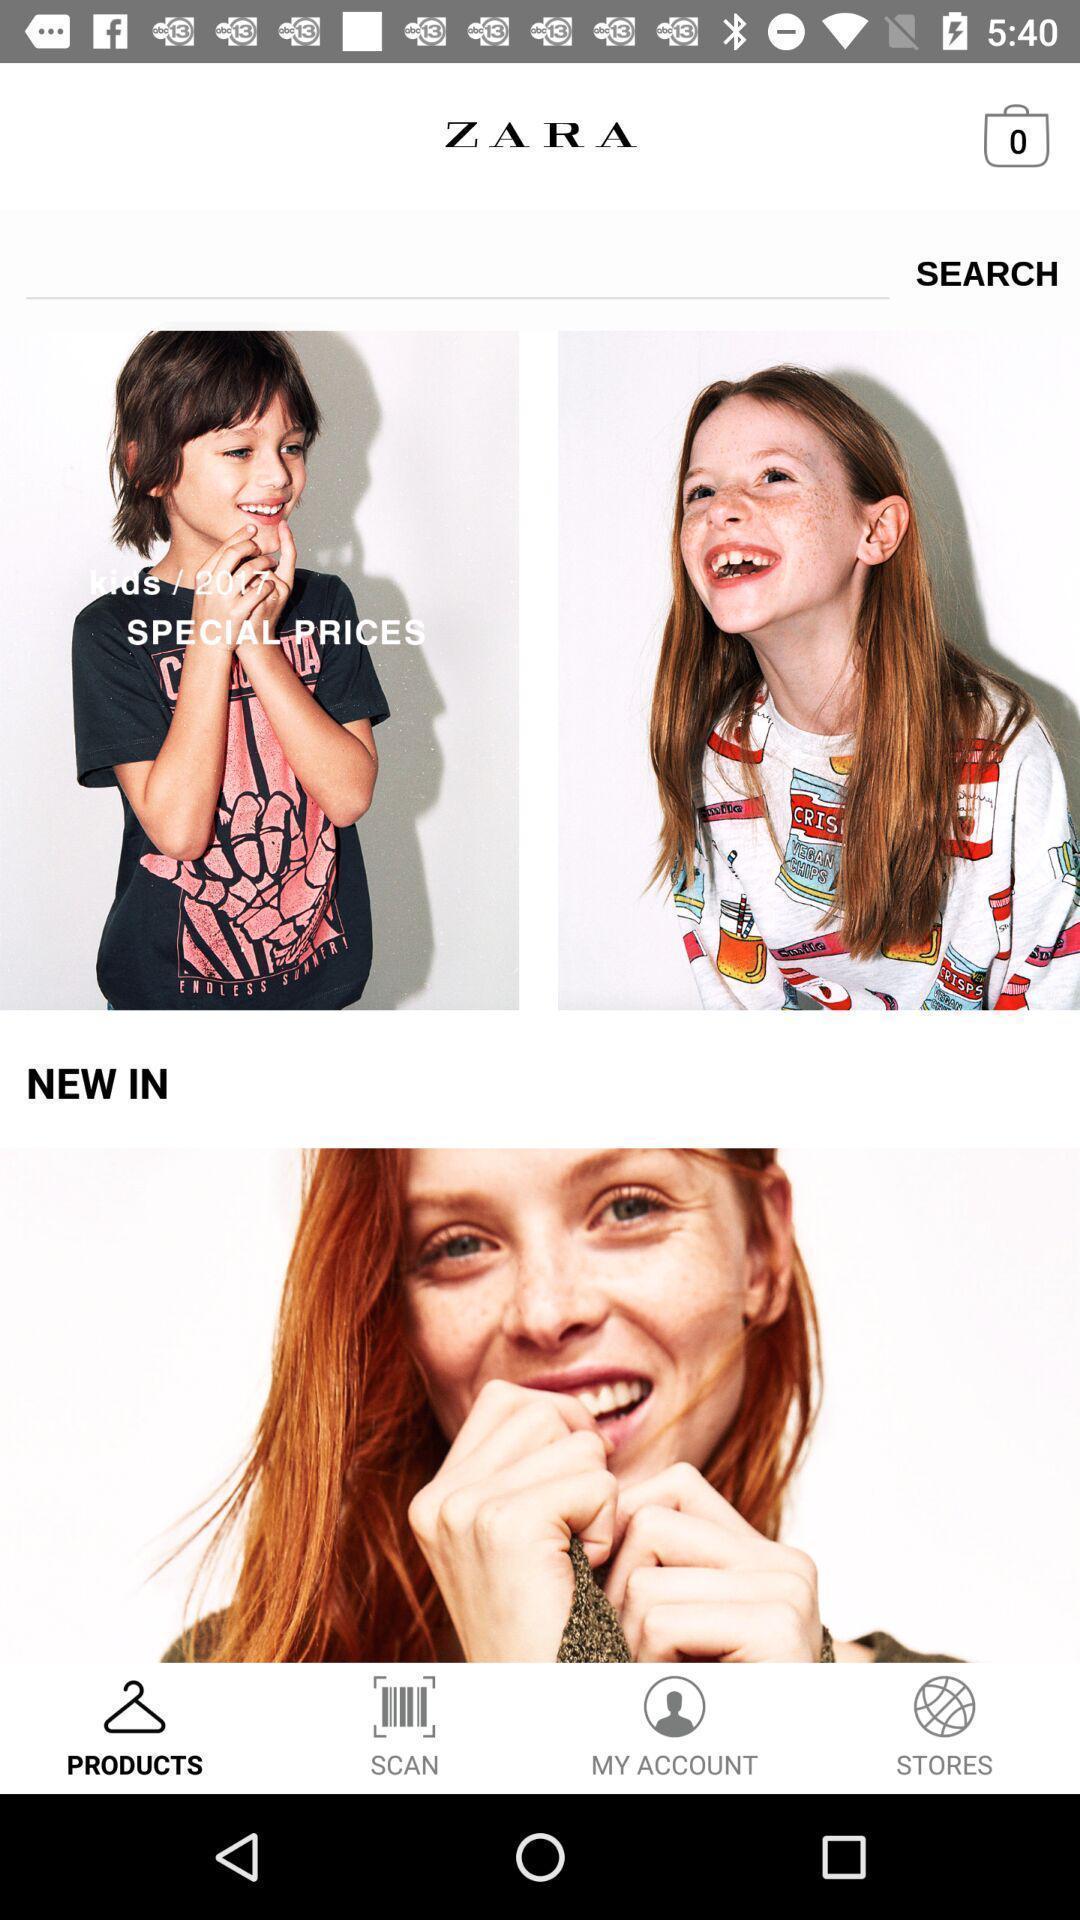What details can you identify in this image? Page showing the categories in shopping app. 